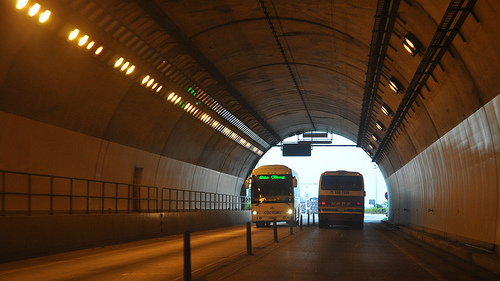<image>
Is the bus to the left of the bus? Yes. From this viewpoint, the bus is positioned to the left side relative to the bus. 